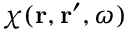Convert formula to latex. <formula><loc_0><loc_0><loc_500><loc_500>\chi ( { r } , { r } ^ { \prime } , \omega )</formula> 